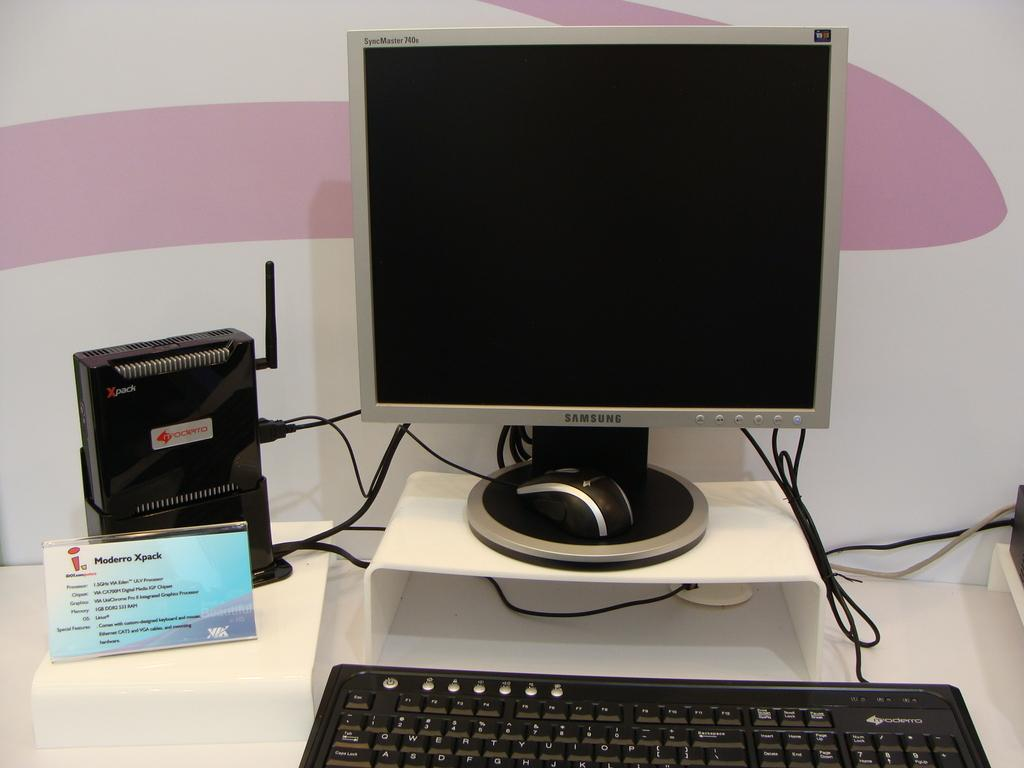What type of electronic device is in the image? There is a personal computer in the image. Are there any other electronic devices present besides the personal computer? Yes, there are electronic devices in the image. What can be seen connecting the electronic devices in the image? Wires are visible in the image. Where is the kitty wearing a crown in the plantation in the image? There is no kitty, crown, or plantation present in the image. 